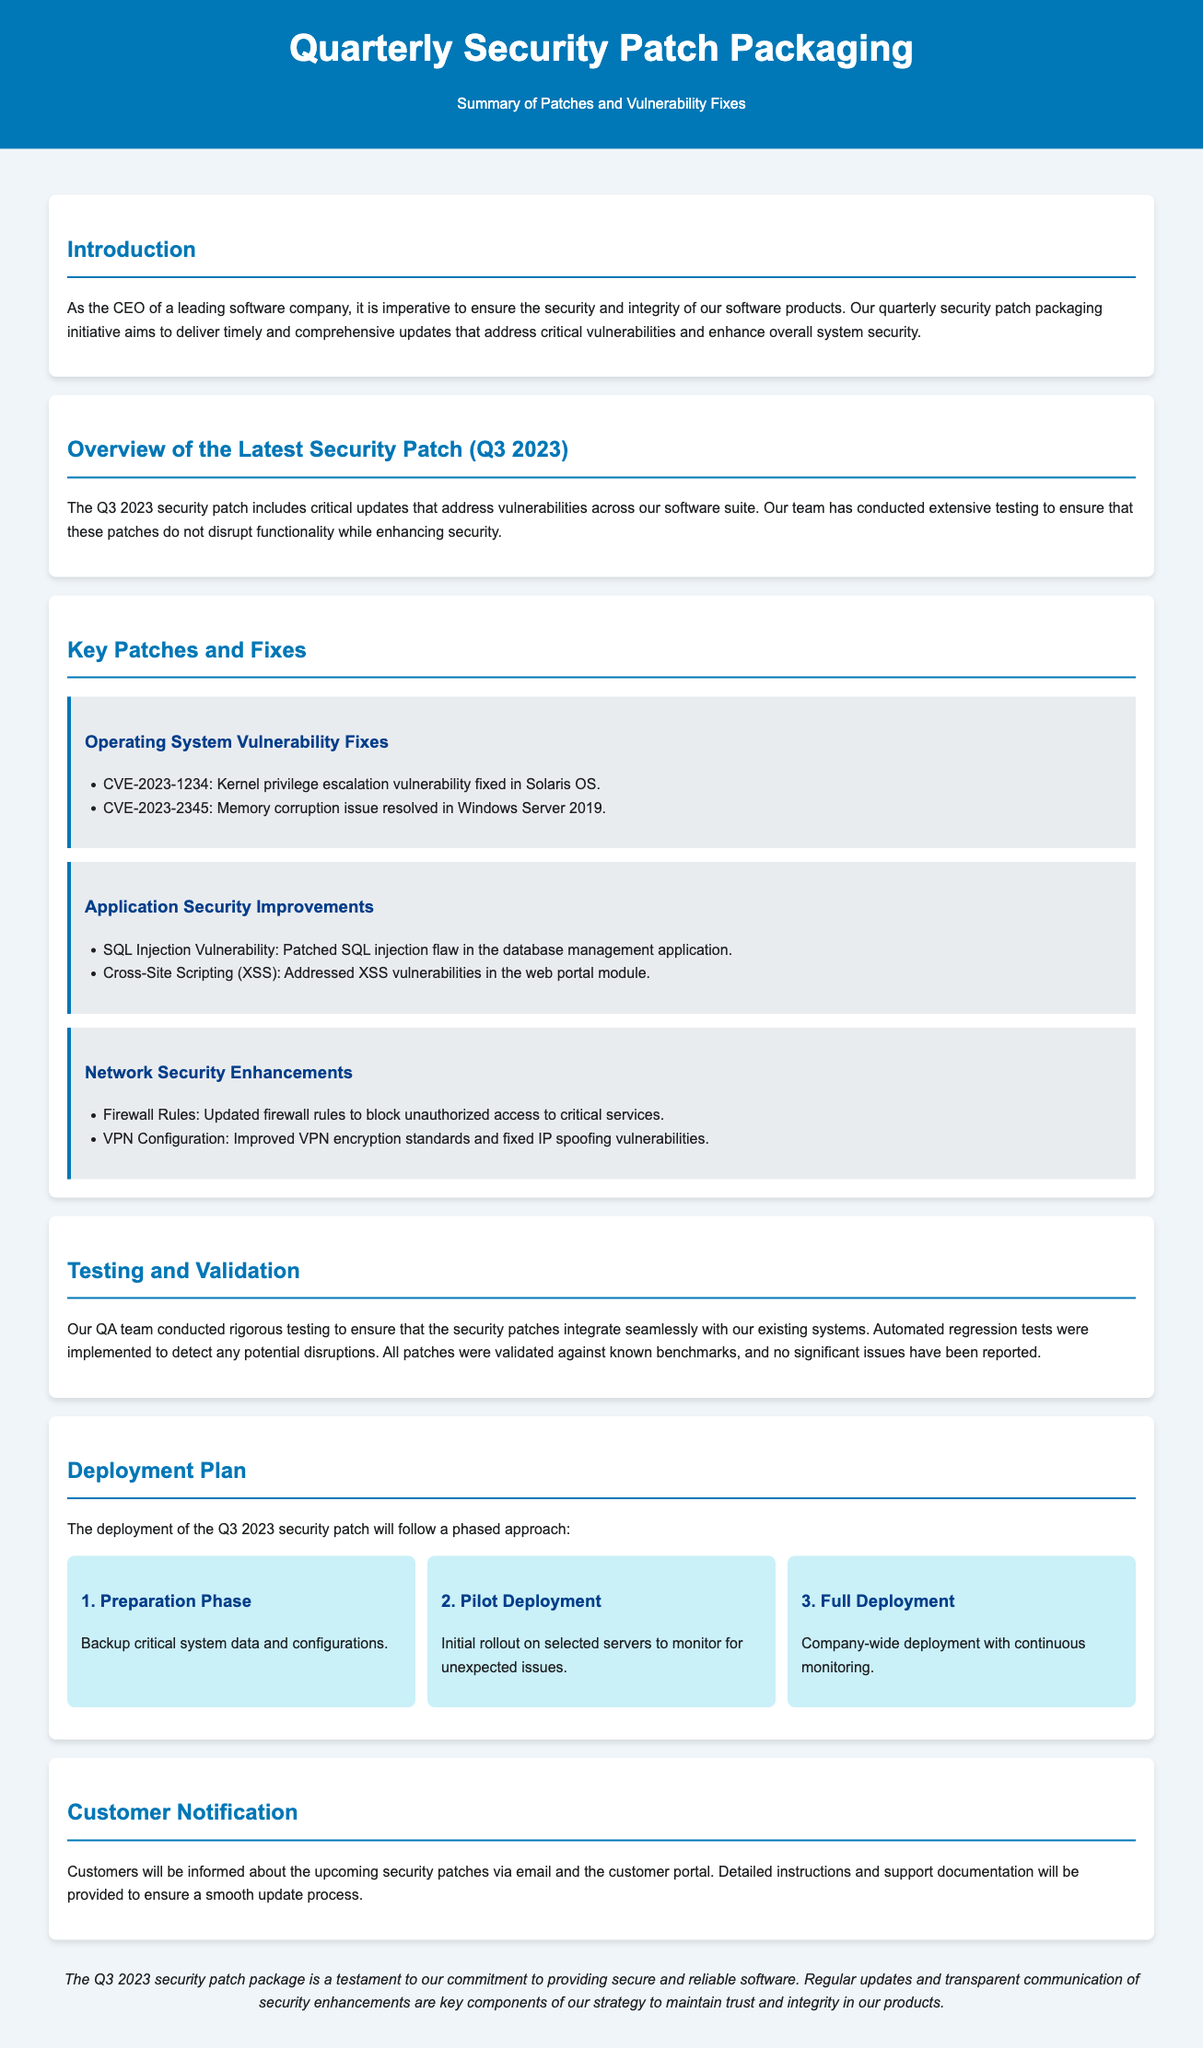What is the title of the document? The title appears in the main header of the document, which is "Quarterly Security Patch Packaging."
Answer: Quarterly Security Patch Packaging When was the latest security patch released? The document refers to the latest security patch as Q3 2023.
Answer: Q3 2023 What vulnerability was fixed in Solaris OS? A specific vulnerability is mentioned: CVE-2023-1234 is identified as fixed, which relates to the Solaris OS.
Answer: CVE-2023-1234 How many phases are in the deployment plan? The deployment plan describes three distinct phases for rollout, which are outlined clearly.
Answer: 3 What method will be used for customer notification? The document states customers will be notified via email and the customer portal.
Answer: Email and customer portal What type of testing was conducted for the patches? The document confirms that rigorous testing was done, including automated regression tests.
Answer: Rigorous testing What is the purpose of the quarterly security patch packaging initiative? The introduction section of the document specifies this initiative's purpose clearly outlined for stakeholders.
Answer: Ensure the security and integrity of our software products What was updated to block unauthorized access? The document lists updated firewall rules as a measure for blocking unauthorized access to critical services.
Answer: Firewall Rules 